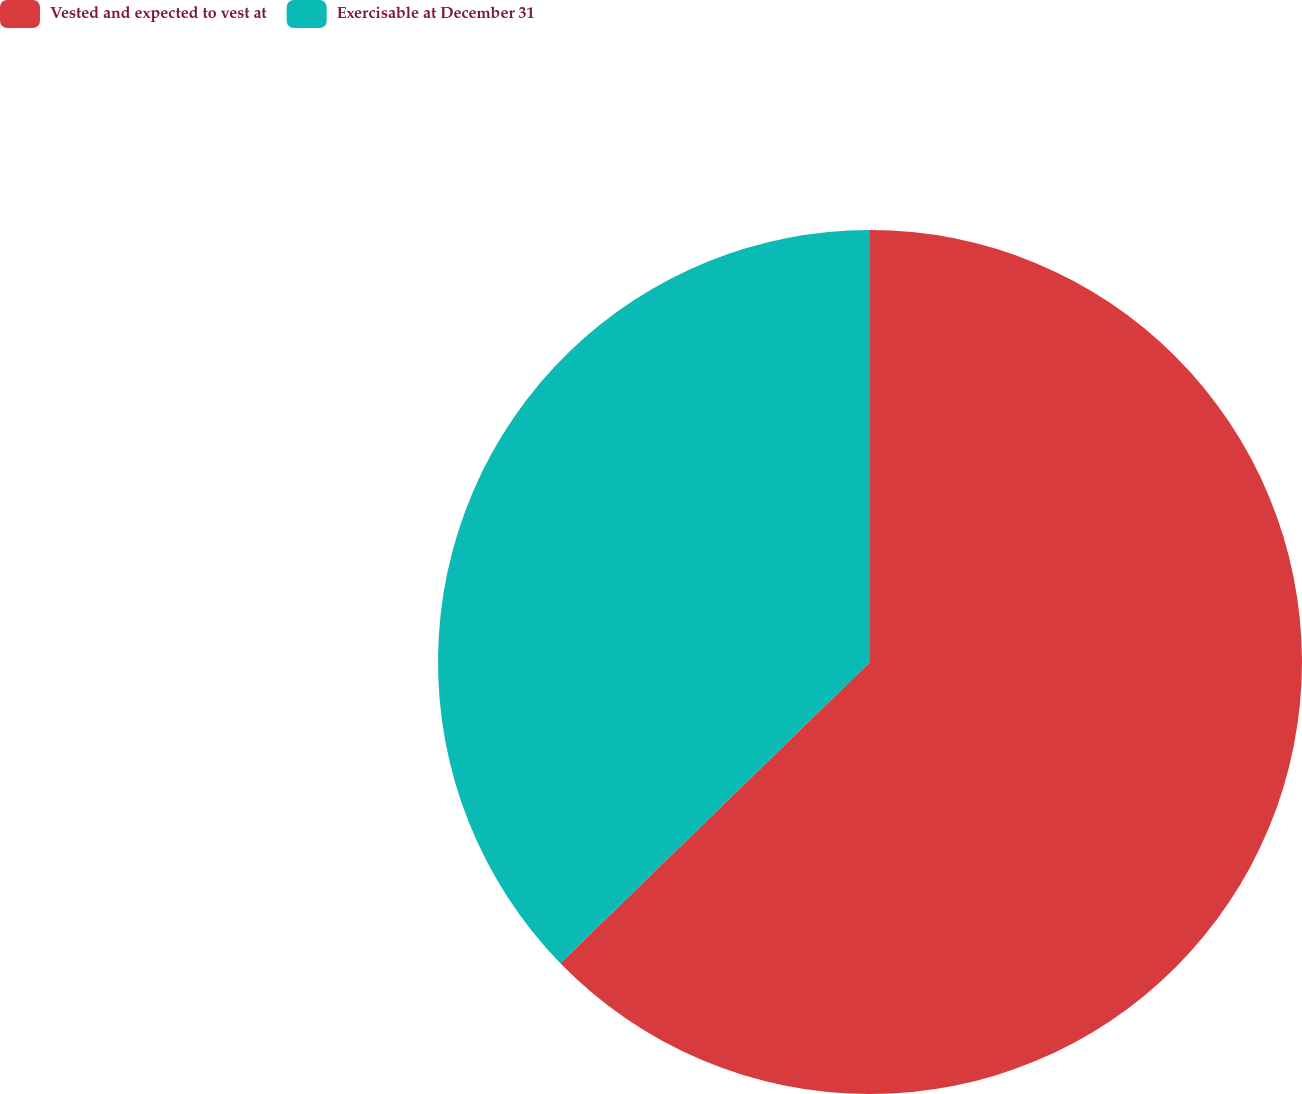Convert chart. <chart><loc_0><loc_0><loc_500><loc_500><pie_chart><fcel>Vested and expected to vest at<fcel>Exercisable at December 31<nl><fcel>62.72%<fcel>37.28%<nl></chart> 